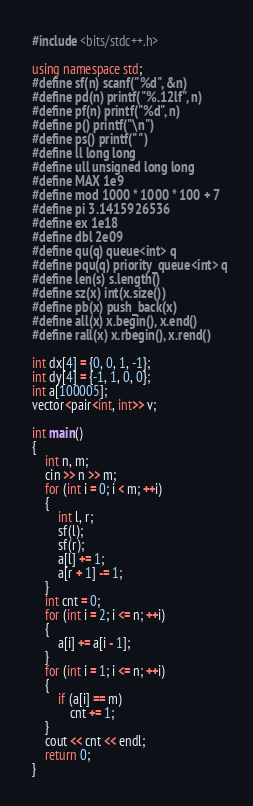Convert code to text. <code><loc_0><loc_0><loc_500><loc_500><_C++_>#include <bits/stdc++.h>

using namespace std;
#define sf(n) scanf("%d", &n)
#define pd(n) printf("%.12lf", n)
#define pf(n) printf("%d", n)
#define p() printf("\n")
#define ps() printf(" ")
#define ll long long
#define ull unsigned long long
#define MAX 1e9
#define mod 1000 * 1000 * 100 + 7
#define pi 3.1415926536
#define ex 1e18
#define dbl 2e09
#define qu(q) queue<int> q
#define pqu(q) priority_queue<int> q
#define len(s) s.length()
#define sz(x) int(x.size())
#define pb(x) push_back(x)
#define all(x) x.begin(), x.end()
#define rall(x) x.rbegin(), x.rend()

int dx[4] = {0, 0, 1, -1};
int dy[4] = {-1, 1, 0, 0};
int a[100005];
vector<pair<int, int>> v;

int main()
{
    int n, m;
    cin >> n >> m;
    for (int i = 0; i < m; ++i)
    {
        int l, r;
        sf(l);
        sf(r);
        a[l] += 1;
        a[r + 1] -= 1;
    }
    int cnt = 0;
    for (int i = 2; i <= n; ++i)
    {
        a[i] += a[i - 1];
    }
    for (int i = 1; i <= n; ++i)
    {
        if (a[i] == m)
            cnt += 1;
    }
    cout << cnt << endl;
    return 0;
}
</code> 